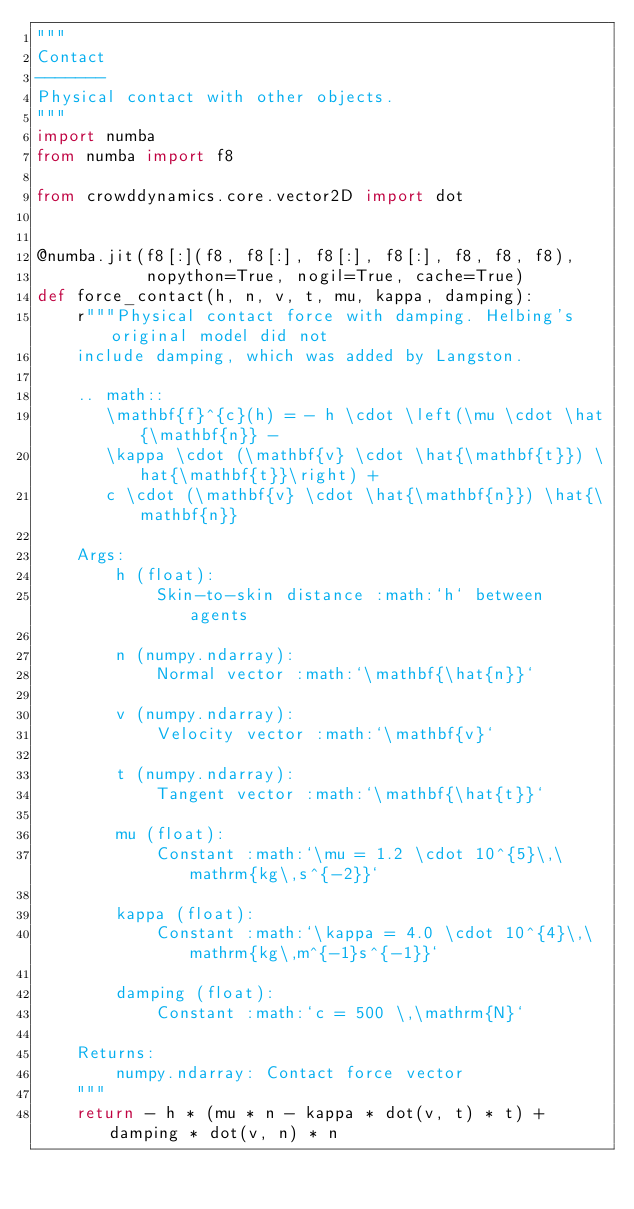<code> <loc_0><loc_0><loc_500><loc_500><_Python_>"""
Contact
-------
Physical contact with other objects.
"""
import numba
from numba import f8

from crowddynamics.core.vector2D import dot


@numba.jit(f8[:](f8, f8[:], f8[:], f8[:], f8, f8, f8),
           nopython=True, nogil=True, cache=True)
def force_contact(h, n, v, t, mu, kappa, damping):
    r"""Physical contact force with damping. Helbing's original model did not
    include damping, which was added by Langston.

    .. math::
       \mathbf{f}^{c}(h) = - h \cdot \left(\mu \cdot \hat{\mathbf{n}} -
       \kappa \cdot (\mathbf{v} \cdot \hat{\mathbf{t}}) \hat{\mathbf{t}}\right) +
       c \cdot (\mathbf{v} \cdot \hat{\mathbf{n}}) \hat{\mathbf{n}}

    Args:
        h (float):
            Skin-to-skin distance :math:`h` between agents

        n (numpy.ndarray):
            Normal vector :math:`\mathbf{\hat{n}}`

        v (numpy.ndarray):
            Velocity vector :math:`\mathbf{v}`

        t (numpy.ndarray):
            Tangent vector :math:`\mathbf{\hat{t}}`

        mu (float):
            Constant :math:`\mu = 1.2 \cdot 10^{5}\,\mathrm{kg\,s^{-2}}`

        kappa (float):
            Constant :math:`\kappa = 4.0 \cdot 10^{4}\,\mathrm{kg\,m^{-1}s^{-1}}`

        damping (float):
            Constant :math:`c = 500 \,\mathrm{N}`

    Returns:
        numpy.ndarray: Contact force vector
    """
    return - h * (mu * n - kappa * dot(v, t) * t) + damping * dot(v, n) * n
</code> 